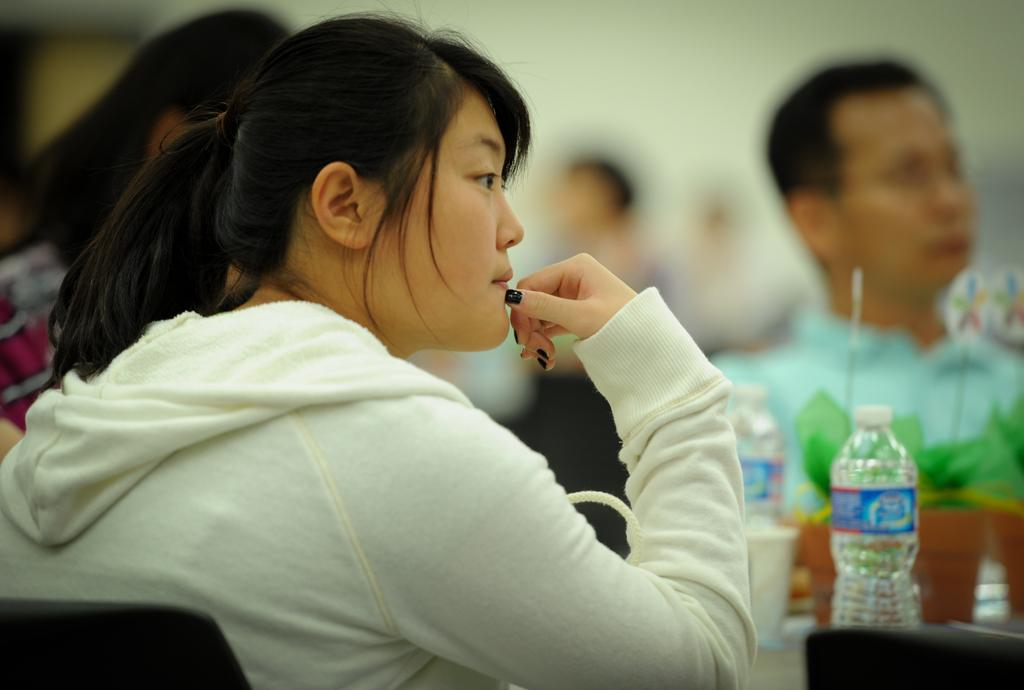What is the woman in the image doing? The woman is sitting in the image. What objects are in front of the woman? There are 2 bottles in front of the woman. Can you describe the people in the background of the image? The people in the background are blurred, making it difficult to see their features. What type of hat is the woman wearing in the image? There is no hat visible in the image; the woman is not wearing one. How many beads can be seen on the woman's necklace in the image? There is no necklace or beads present in the image. 